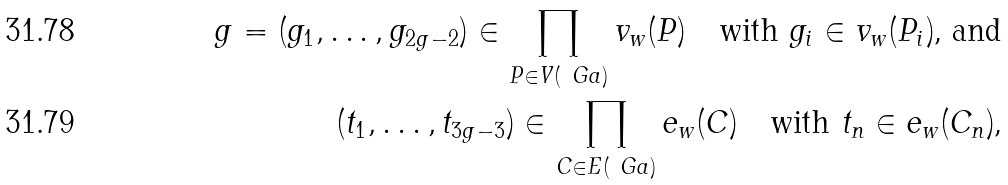Convert formula to latex. <formula><loc_0><loc_0><loc_500><loc_500>g = ( g _ { 1 } , \dots , g _ { 2 g - 2 } ) \in \prod _ { P \in V ( \ G a ) } v _ { w } ( P ) \quad \text {with $g_{i}\in v_{w}(P_{i})$, and} \\ ( t _ { 1 } , \dots , t _ { 3 g - 3 } ) \in \prod _ { C \in E ( \ G a ) } e _ { w } ( C ) \quad \text {with $t_{n}\in e_{w}(C_{n})$,}</formula> 